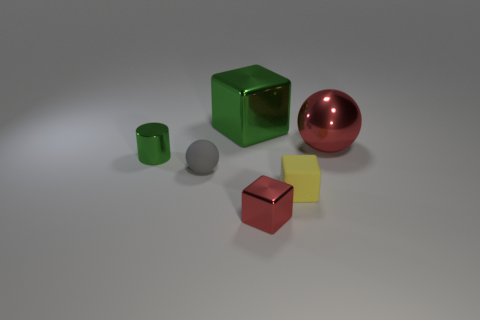Add 1 blocks. How many objects exist? 7 Subtract all small blocks. How many blocks are left? 1 Subtract all red balls. How many balls are left? 1 Subtract 1 balls. How many balls are left? 1 Subtract all spheres. How many objects are left? 4 Subtract all green spheres. Subtract all red objects. How many objects are left? 4 Add 5 gray rubber spheres. How many gray rubber spheres are left? 6 Add 2 red shiny cubes. How many red shiny cubes exist? 3 Subtract 1 red blocks. How many objects are left? 5 Subtract all purple cylinders. Subtract all purple cubes. How many cylinders are left? 1 